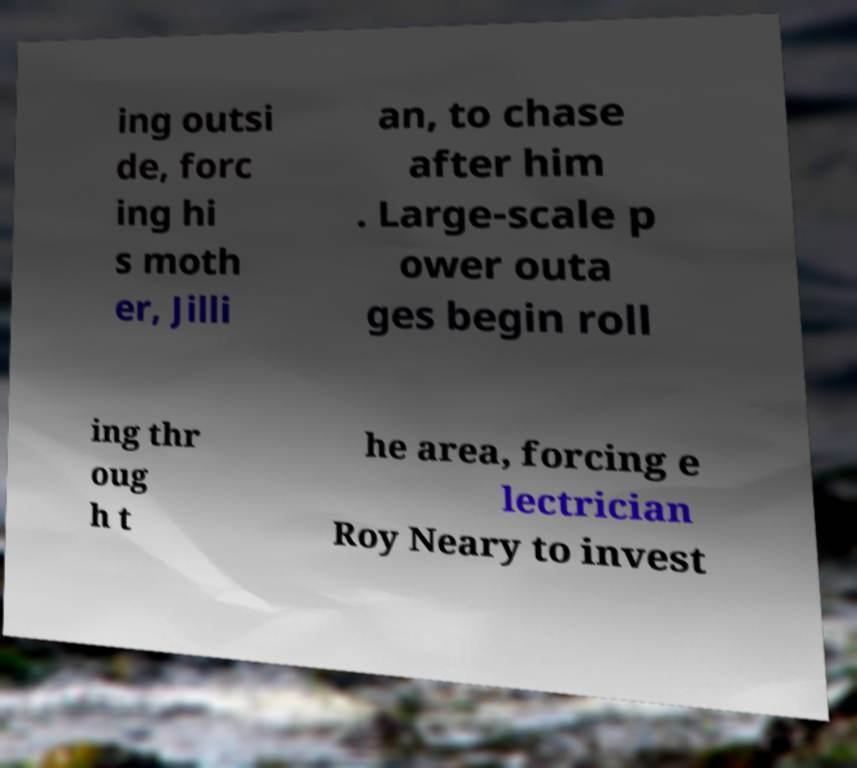Can you accurately transcribe the text from the provided image for me? ing outsi de, forc ing hi s moth er, Jilli an, to chase after him . Large-scale p ower outa ges begin roll ing thr oug h t he area, forcing e lectrician Roy Neary to invest 